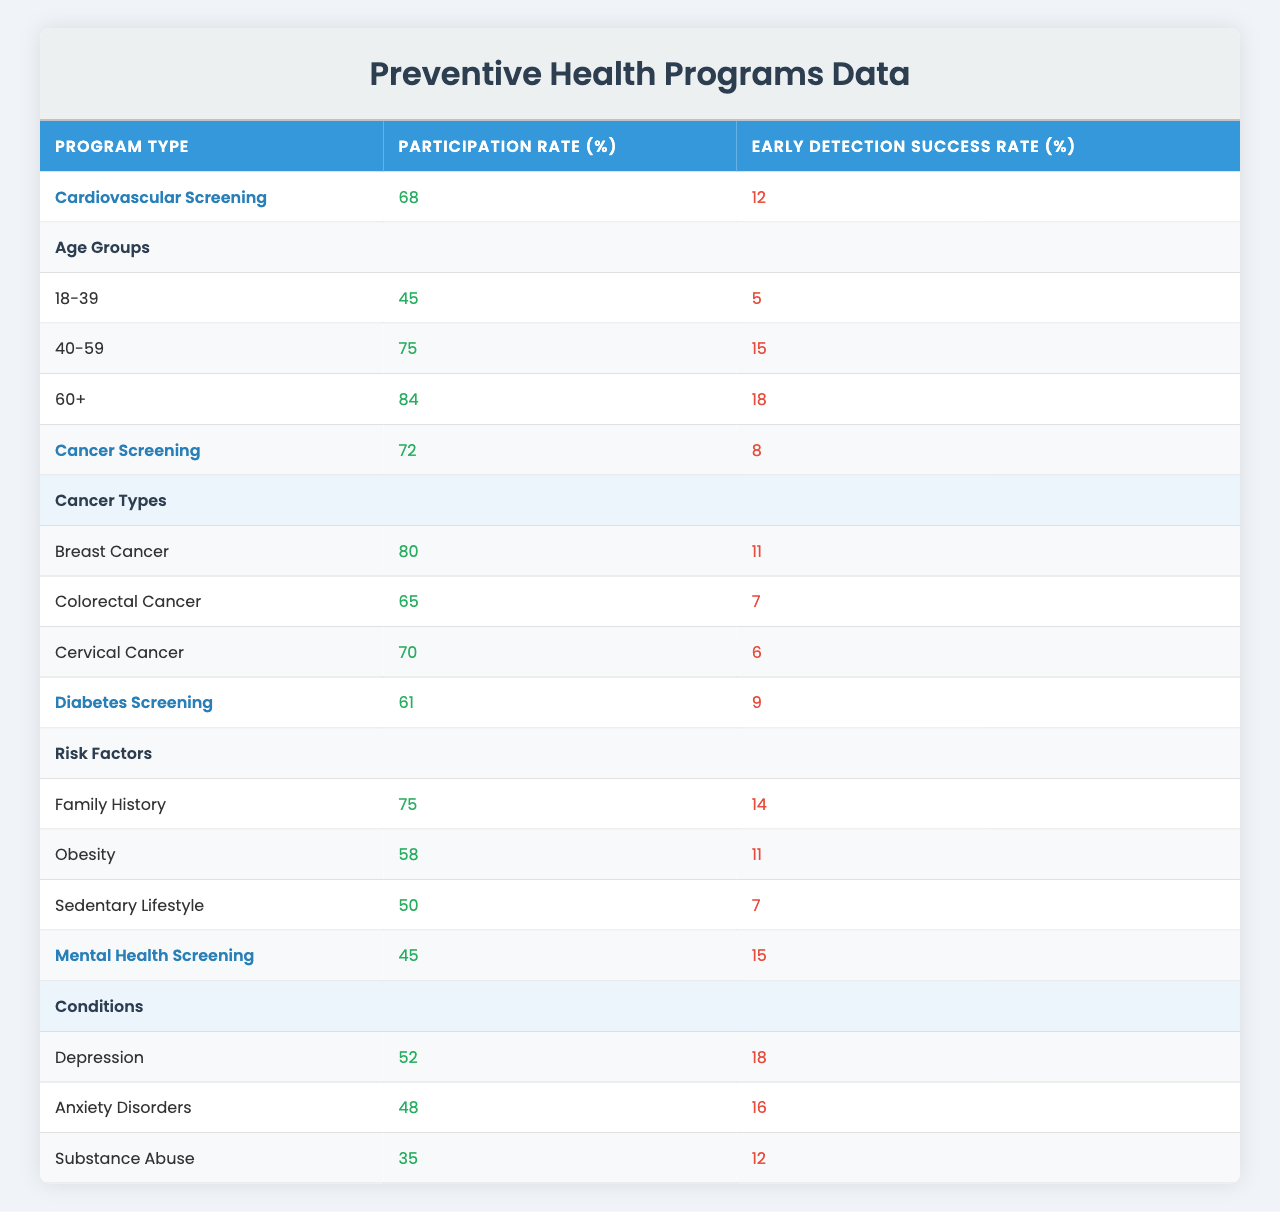What is the participation rate for Diabetes Screening? The table shows that the participation rate for the Diabetes Screening program is 61%.
Answer: 61% Which program type has the highest early detection success rate? The Cardiovascular Screening program has the highest early detection success rate at 12%.
Answer: 12% What is the participation rate for the age group 60+ in the Cardiovascular Screening program? The table indicates that the participation rate for the age group 60+ in the Cardiovascular Screening program is 84%.
Answer: 84% Which cancer type has the lowest early detection success rate? Among all specified cancer types, Colorectal Cancer has the lowest early detection success rate at 7%.
Answer: 7% What is the average participation rate across all Preventive Health Programs? The participation rates are 68, 72, 61, and 45. Adding them results in 246, and dividing by the number of programs (4) gives an average of 61.5.
Answer: 61.5 Is the participation rate for Breast Cancer screening higher than that for Cervical Cancer screening? Yes, the Breast Cancer screening participation rate is 80%, while the Cervical Cancer screening participation rate is 70%.
Answer: Yes What is the total participation rate of age groups in Cardiovascular Screening? The age groups have participation rates of 45 (18-39), 75 (40-59), and 84 (60+), resulting in a total of 204.
Answer: 204 How does the early detection success rate for Mental Health Screening compare to that for Cancer Screening? The early detection success rate for Mental Health Screening is 15%, whereas it is 8% for Cancer Screening. Therefore, Mental Health Screening has a higher rate.
Answer: Higher What is the difference in participation rates between the 40-59 age group and the 60+ age group in Cardiovascular Screening? The participation rate for the 40-59 age group is 75%, and for the 60+ age group it is 84%. The difference is 84 - 75 = 9%.
Answer: 9% Which risk factor in Diabetes Screening has the highest early detection success rate? Among the risk factors, Family History has the highest early detection success rate at 14%.
Answer: 14% 